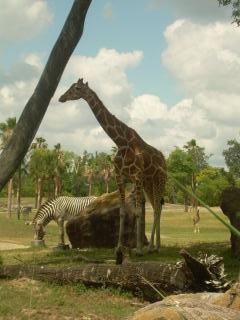Describe the objects in this image and their specific colors. I can see giraffe in lightgray, black, darkgreen, and gray tones and zebra in lightgray, olive, and tan tones in this image. 